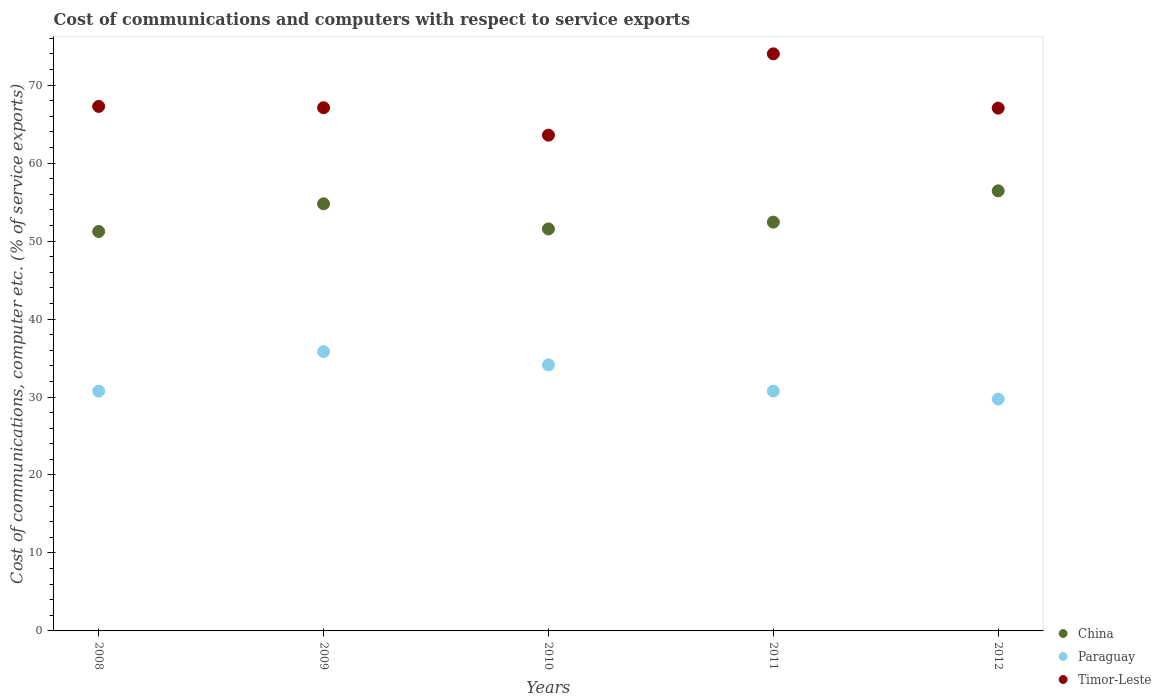How many different coloured dotlines are there?
Give a very brief answer. 3. What is the cost of communications and computers in Timor-Leste in 2011?
Your response must be concise. 74.01. Across all years, what is the maximum cost of communications and computers in Paraguay?
Your answer should be compact. 35.82. Across all years, what is the minimum cost of communications and computers in Timor-Leste?
Give a very brief answer. 63.58. In which year was the cost of communications and computers in China maximum?
Offer a terse response. 2012. What is the total cost of communications and computers in China in the graph?
Ensure brevity in your answer.  266.42. What is the difference between the cost of communications and computers in Timor-Leste in 2008 and that in 2012?
Provide a succinct answer. 0.22. What is the difference between the cost of communications and computers in Paraguay in 2012 and the cost of communications and computers in Timor-Leste in 2008?
Ensure brevity in your answer.  -37.54. What is the average cost of communications and computers in Timor-Leste per year?
Provide a short and direct response. 67.8. In the year 2008, what is the difference between the cost of communications and computers in Timor-Leste and cost of communications and computers in Paraguay?
Offer a terse response. 36.51. What is the ratio of the cost of communications and computers in Timor-Leste in 2009 to that in 2010?
Ensure brevity in your answer.  1.06. Is the cost of communications and computers in Timor-Leste in 2010 less than that in 2012?
Offer a very short reply. Yes. Is the difference between the cost of communications and computers in Timor-Leste in 2010 and 2012 greater than the difference between the cost of communications and computers in Paraguay in 2010 and 2012?
Give a very brief answer. No. What is the difference between the highest and the second highest cost of communications and computers in Paraguay?
Give a very brief answer. 1.7. What is the difference between the highest and the lowest cost of communications and computers in China?
Your response must be concise. 5.21. In how many years, is the cost of communications and computers in Paraguay greater than the average cost of communications and computers in Paraguay taken over all years?
Give a very brief answer. 2. Is the sum of the cost of communications and computers in Paraguay in 2010 and 2011 greater than the maximum cost of communications and computers in China across all years?
Offer a very short reply. Yes. Does the cost of communications and computers in Paraguay monotonically increase over the years?
Your response must be concise. No. How many dotlines are there?
Offer a very short reply. 3. What is the difference between two consecutive major ticks on the Y-axis?
Your response must be concise. 10. Does the graph contain grids?
Make the answer very short. No. Where does the legend appear in the graph?
Make the answer very short. Bottom right. How are the legend labels stacked?
Make the answer very short. Vertical. What is the title of the graph?
Give a very brief answer. Cost of communications and computers with respect to service exports. Does "Qatar" appear as one of the legend labels in the graph?
Ensure brevity in your answer.  No. What is the label or title of the Y-axis?
Offer a very short reply. Cost of communications, computer etc. (% of service exports). What is the Cost of communications, computer etc. (% of service exports) of China in 2008?
Your response must be concise. 51.23. What is the Cost of communications, computer etc. (% of service exports) of Paraguay in 2008?
Your answer should be very brief. 30.76. What is the Cost of communications, computer etc. (% of service exports) in Timor-Leste in 2008?
Make the answer very short. 67.27. What is the Cost of communications, computer etc. (% of service exports) in China in 2009?
Provide a short and direct response. 54.78. What is the Cost of communications, computer etc. (% of service exports) in Paraguay in 2009?
Your answer should be very brief. 35.82. What is the Cost of communications, computer etc. (% of service exports) of Timor-Leste in 2009?
Offer a terse response. 67.1. What is the Cost of communications, computer etc. (% of service exports) of China in 2010?
Offer a terse response. 51.55. What is the Cost of communications, computer etc. (% of service exports) in Paraguay in 2010?
Make the answer very short. 34.12. What is the Cost of communications, computer etc. (% of service exports) in Timor-Leste in 2010?
Your answer should be very brief. 63.58. What is the Cost of communications, computer etc. (% of service exports) in China in 2011?
Your response must be concise. 52.43. What is the Cost of communications, computer etc. (% of service exports) in Paraguay in 2011?
Give a very brief answer. 30.76. What is the Cost of communications, computer etc. (% of service exports) in Timor-Leste in 2011?
Keep it short and to the point. 74.01. What is the Cost of communications, computer etc. (% of service exports) of China in 2012?
Your response must be concise. 56.44. What is the Cost of communications, computer etc. (% of service exports) of Paraguay in 2012?
Keep it short and to the point. 29.73. What is the Cost of communications, computer etc. (% of service exports) in Timor-Leste in 2012?
Make the answer very short. 67.05. Across all years, what is the maximum Cost of communications, computer etc. (% of service exports) in China?
Provide a succinct answer. 56.44. Across all years, what is the maximum Cost of communications, computer etc. (% of service exports) in Paraguay?
Keep it short and to the point. 35.82. Across all years, what is the maximum Cost of communications, computer etc. (% of service exports) of Timor-Leste?
Provide a succinct answer. 74.01. Across all years, what is the minimum Cost of communications, computer etc. (% of service exports) in China?
Your response must be concise. 51.23. Across all years, what is the minimum Cost of communications, computer etc. (% of service exports) of Paraguay?
Your answer should be compact. 29.73. Across all years, what is the minimum Cost of communications, computer etc. (% of service exports) of Timor-Leste?
Give a very brief answer. 63.58. What is the total Cost of communications, computer etc. (% of service exports) in China in the graph?
Offer a very short reply. 266.42. What is the total Cost of communications, computer etc. (% of service exports) in Paraguay in the graph?
Your answer should be compact. 161.18. What is the total Cost of communications, computer etc. (% of service exports) in Timor-Leste in the graph?
Provide a succinct answer. 339.01. What is the difference between the Cost of communications, computer etc. (% of service exports) in China in 2008 and that in 2009?
Your response must be concise. -3.55. What is the difference between the Cost of communications, computer etc. (% of service exports) of Paraguay in 2008 and that in 2009?
Your answer should be compact. -5.06. What is the difference between the Cost of communications, computer etc. (% of service exports) of Timor-Leste in 2008 and that in 2009?
Ensure brevity in your answer.  0.17. What is the difference between the Cost of communications, computer etc. (% of service exports) of China in 2008 and that in 2010?
Provide a succinct answer. -0.33. What is the difference between the Cost of communications, computer etc. (% of service exports) of Paraguay in 2008 and that in 2010?
Offer a terse response. -3.36. What is the difference between the Cost of communications, computer etc. (% of service exports) of Timor-Leste in 2008 and that in 2010?
Make the answer very short. 3.69. What is the difference between the Cost of communications, computer etc. (% of service exports) in China in 2008 and that in 2011?
Your answer should be very brief. -1.2. What is the difference between the Cost of communications, computer etc. (% of service exports) in Paraguay in 2008 and that in 2011?
Make the answer very short. -0. What is the difference between the Cost of communications, computer etc. (% of service exports) of Timor-Leste in 2008 and that in 2011?
Give a very brief answer. -6.74. What is the difference between the Cost of communications, computer etc. (% of service exports) in China in 2008 and that in 2012?
Your response must be concise. -5.21. What is the difference between the Cost of communications, computer etc. (% of service exports) in Timor-Leste in 2008 and that in 2012?
Make the answer very short. 0.22. What is the difference between the Cost of communications, computer etc. (% of service exports) of China in 2009 and that in 2010?
Offer a terse response. 3.23. What is the difference between the Cost of communications, computer etc. (% of service exports) of Paraguay in 2009 and that in 2010?
Give a very brief answer. 1.7. What is the difference between the Cost of communications, computer etc. (% of service exports) in Timor-Leste in 2009 and that in 2010?
Offer a terse response. 3.52. What is the difference between the Cost of communications, computer etc. (% of service exports) in China in 2009 and that in 2011?
Keep it short and to the point. 2.35. What is the difference between the Cost of communications, computer etc. (% of service exports) in Paraguay in 2009 and that in 2011?
Your answer should be very brief. 5.06. What is the difference between the Cost of communications, computer etc. (% of service exports) of Timor-Leste in 2009 and that in 2011?
Your response must be concise. -6.91. What is the difference between the Cost of communications, computer etc. (% of service exports) in China in 2009 and that in 2012?
Make the answer very short. -1.66. What is the difference between the Cost of communications, computer etc. (% of service exports) of Paraguay in 2009 and that in 2012?
Provide a short and direct response. 6.09. What is the difference between the Cost of communications, computer etc. (% of service exports) of Timor-Leste in 2009 and that in 2012?
Give a very brief answer. 0.05. What is the difference between the Cost of communications, computer etc. (% of service exports) of China in 2010 and that in 2011?
Provide a succinct answer. -0.87. What is the difference between the Cost of communications, computer etc. (% of service exports) of Paraguay in 2010 and that in 2011?
Provide a succinct answer. 3.36. What is the difference between the Cost of communications, computer etc. (% of service exports) of Timor-Leste in 2010 and that in 2011?
Your answer should be compact. -10.43. What is the difference between the Cost of communications, computer etc. (% of service exports) of China in 2010 and that in 2012?
Ensure brevity in your answer.  -4.89. What is the difference between the Cost of communications, computer etc. (% of service exports) in Paraguay in 2010 and that in 2012?
Your answer should be compact. 4.39. What is the difference between the Cost of communications, computer etc. (% of service exports) in Timor-Leste in 2010 and that in 2012?
Offer a very short reply. -3.47. What is the difference between the Cost of communications, computer etc. (% of service exports) of China in 2011 and that in 2012?
Your answer should be compact. -4.02. What is the difference between the Cost of communications, computer etc. (% of service exports) in Paraguay in 2011 and that in 2012?
Provide a succinct answer. 1.03. What is the difference between the Cost of communications, computer etc. (% of service exports) of Timor-Leste in 2011 and that in 2012?
Give a very brief answer. 6.96. What is the difference between the Cost of communications, computer etc. (% of service exports) in China in 2008 and the Cost of communications, computer etc. (% of service exports) in Paraguay in 2009?
Your answer should be compact. 15.41. What is the difference between the Cost of communications, computer etc. (% of service exports) of China in 2008 and the Cost of communications, computer etc. (% of service exports) of Timor-Leste in 2009?
Provide a succinct answer. -15.87. What is the difference between the Cost of communications, computer etc. (% of service exports) in Paraguay in 2008 and the Cost of communications, computer etc. (% of service exports) in Timor-Leste in 2009?
Make the answer very short. -36.34. What is the difference between the Cost of communications, computer etc. (% of service exports) of China in 2008 and the Cost of communications, computer etc. (% of service exports) of Paraguay in 2010?
Give a very brief answer. 17.11. What is the difference between the Cost of communications, computer etc. (% of service exports) in China in 2008 and the Cost of communications, computer etc. (% of service exports) in Timor-Leste in 2010?
Give a very brief answer. -12.35. What is the difference between the Cost of communications, computer etc. (% of service exports) of Paraguay in 2008 and the Cost of communications, computer etc. (% of service exports) of Timor-Leste in 2010?
Offer a terse response. -32.82. What is the difference between the Cost of communications, computer etc. (% of service exports) of China in 2008 and the Cost of communications, computer etc. (% of service exports) of Paraguay in 2011?
Your answer should be compact. 20.47. What is the difference between the Cost of communications, computer etc. (% of service exports) in China in 2008 and the Cost of communications, computer etc. (% of service exports) in Timor-Leste in 2011?
Give a very brief answer. -22.78. What is the difference between the Cost of communications, computer etc. (% of service exports) in Paraguay in 2008 and the Cost of communications, computer etc. (% of service exports) in Timor-Leste in 2011?
Offer a terse response. -43.25. What is the difference between the Cost of communications, computer etc. (% of service exports) in China in 2008 and the Cost of communications, computer etc. (% of service exports) in Paraguay in 2012?
Provide a short and direct response. 21.5. What is the difference between the Cost of communications, computer etc. (% of service exports) in China in 2008 and the Cost of communications, computer etc. (% of service exports) in Timor-Leste in 2012?
Ensure brevity in your answer.  -15.82. What is the difference between the Cost of communications, computer etc. (% of service exports) in Paraguay in 2008 and the Cost of communications, computer etc. (% of service exports) in Timor-Leste in 2012?
Your answer should be compact. -36.29. What is the difference between the Cost of communications, computer etc. (% of service exports) in China in 2009 and the Cost of communications, computer etc. (% of service exports) in Paraguay in 2010?
Keep it short and to the point. 20.66. What is the difference between the Cost of communications, computer etc. (% of service exports) in China in 2009 and the Cost of communications, computer etc. (% of service exports) in Timor-Leste in 2010?
Offer a very short reply. -8.8. What is the difference between the Cost of communications, computer etc. (% of service exports) of Paraguay in 2009 and the Cost of communications, computer etc. (% of service exports) of Timor-Leste in 2010?
Provide a succinct answer. -27.76. What is the difference between the Cost of communications, computer etc. (% of service exports) in China in 2009 and the Cost of communications, computer etc. (% of service exports) in Paraguay in 2011?
Your response must be concise. 24.02. What is the difference between the Cost of communications, computer etc. (% of service exports) of China in 2009 and the Cost of communications, computer etc. (% of service exports) of Timor-Leste in 2011?
Offer a terse response. -19.23. What is the difference between the Cost of communications, computer etc. (% of service exports) in Paraguay in 2009 and the Cost of communications, computer etc. (% of service exports) in Timor-Leste in 2011?
Your answer should be compact. -38.19. What is the difference between the Cost of communications, computer etc. (% of service exports) in China in 2009 and the Cost of communications, computer etc. (% of service exports) in Paraguay in 2012?
Keep it short and to the point. 25.05. What is the difference between the Cost of communications, computer etc. (% of service exports) of China in 2009 and the Cost of communications, computer etc. (% of service exports) of Timor-Leste in 2012?
Offer a terse response. -12.27. What is the difference between the Cost of communications, computer etc. (% of service exports) in Paraguay in 2009 and the Cost of communications, computer etc. (% of service exports) in Timor-Leste in 2012?
Make the answer very short. -31.23. What is the difference between the Cost of communications, computer etc. (% of service exports) of China in 2010 and the Cost of communications, computer etc. (% of service exports) of Paraguay in 2011?
Your answer should be compact. 20.79. What is the difference between the Cost of communications, computer etc. (% of service exports) of China in 2010 and the Cost of communications, computer etc. (% of service exports) of Timor-Leste in 2011?
Give a very brief answer. -22.46. What is the difference between the Cost of communications, computer etc. (% of service exports) in Paraguay in 2010 and the Cost of communications, computer etc. (% of service exports) in Timor-Leste in 2011?
Provide a succinct answer. -39.89. What is the difference between the Cost of communications, computer etc. (% of service exports) of China in 2010 and the Cost of communications, computer etc. (% of service exports) of Paraguay in 2012?
Offer a terse response. 21.82. What is the difference between the Cost of communications, computer etc. (% of service exports) of China in 2010 and the Cost of communications, computer etc. (% of service exports) of Timor-Leste in 2012?
Provide a succinct answer. -15.49. What is the difference between the Cost of communications, computer etc. (% of service exports) in Paraguay in 2010 and the Cost of communications, computer etc. (% of service exports) in Timor-Leste in 2012?
Make the answer very short. -32.93. What is the difference between the Cost of communications, computer etc. (% of service exports) in China in 2011 and the Cost of communications, computer etc. (% of service exports) in Paraguay in 2012?
Make the answer very short. 22.7. What is the difference between the Cost of communications, computer etc. (% of service exports) in China in 2011 and the Cost of communications, computer etc. (% of service exports) in Timor-Leste in 2012?
Your response must be concise. -14.62. What is the difference between the Cost of communications, computer etc. (% of service exports) in Paraguay in 2011 and the Cost of communications, computer etc. (% of service exports) in Timor-Leste in 2012?
Keep it short and to the point. -36.29. What is the average Cost of communications, computer etc. (% of service exports) of China per year?
Your answer should be compact. 53.28. What is the average Cost of communications, computer etc. (% of service exports) in Paraguay per year?
Offer a very short reply. 32.24. What is the average Cost of communications, computer etc. (% of service exports) in Timor-Leste per year?
Your answer should be compact. 67.8. In the year 2008, what is the difference between the Cost of communications, computer etc. (% of service exports) in China and Cost of communications, computer etc. (% of service exports) in Paraguay?
Offer a very short reply. 20.47. In the year 2008, what is the difference between the Cost of communications, computer etc. (% of service exports) of China and Cost of communications, computer etc. (% of service exports) of Timor-Leste?
Give a very brief answer. -16.04. In the year 2008, what is the difference between the Cost of communications, computer etc. (% of service exports) of Paraguay and Cost of communications, computer etc. (% of service exports) of Timor-Leste?
Offer a terse response. -36.51. In the year 2009, what is the difference between the Cost of communications, computer etc. (% of service exports) of China and Cost of communications, computer etc. (% of service exports) of Paraguay?
Provide a succinct answer. 18.96. In the year 2009, what is the difference between the Cost of communications, computer etc. (% of service exports) in China and Cost of communications, computer etc. (% of service exports) in Timor-Leste?
Your answer should be compact. -12.32. In the year 2009, what is the difference between the Cost of communications, computer etc. (% of service exports) of Paraguay and Cost of communications, computer etc. (% of service exports) of Timor-Leste?
Your answer should be very brief. -31.28. In the year 2010, what is the difference between the Cost of communications, computer etc. (% of service exports) of China and Cost of communications, computer etc. (% of service exports) of Paraguay?
Make the answer very short. 17.44. In the year 2010, what is the difference between the Cost of communications, computer etc. (% of service exports) of China and Cost of communications, computer etc. (% of service exports) of Timor-Leste?
Ensure brevity in your answer.  -12.03. In the year 2010, what is the difference between the Cost of communications, computer etc. (% of service exports) of Paraguay and Cost of communications, computer etc. (% of service exports) of Timor-Leste?
Ensure brevity in your answer.  -29.46. In the year 2011, what is the difference between the Cost of communications, computer etc. (% of service exports) of China and Cost of communications, computer etc. (% of service exports) of Paraguay?
Give a very brief answer. 21.67. In the year 2011, what is the difference between the Cost of communications, computer etc. (% of service exports) in China and Cost of communications, computer etc. (% of service exports) in Timor-Leste?
Your answer should be compact. -21.59. In the year 2011, what is the difference between the Cost of communications, computer etc. (% of service exports) in Paraguay and Cost of communications, computer etc. (% of service exports) in Timor-Leste?
Provide a short and direct response. -43.25. In the year 2012, what is the difference between the Cost of communications, computer etc. (% of service exports) of China and Cost of communications, computer etc. (% of service exports) of Paraguay?
Keep it short and to the point. 26.71. In the year 2012, what is the difference between the Cost of communications, computer etc. (% of service exports) in China and Cost of communications, computer etc. (% of service exports) in Timor-Leste?
Give a very brief answer. -10.61. In the year 2012, what is the difference between the Cost of communications, computer etc. (% of service exports) of Paraguay and Cost of communications, computer etc. (% of service exports) of Timor-Leste?
Your answer should be very brief. -37.32. What is the ratio of the Cost of communications, computer etc. (% of service exports) of China in 2008 to that in 2009?
Make the answer very short. 0.94. What is the ratio of the Cost of communications, computer etc. (% of service exports) of Paraguay in 2008 to that in 2009?
Your response must be concise. 0.86. What is the ratio of the Cost of communications, computer etc. (% of service exports) in Timor-Leste in 2008 to that in 2009?
Keep it short and to the point. 1. What is the ratio of the Cost of communications, computer etc. (% of service exports) in Paraguay in 2008 to that in 2010?
Give a very brief answer. 0.9. What is the ratio of the Cost of communications, computer etc. (% of service exports) of Timor-Leste in 2008 to that in 2010?
Make the answer very short. 1.06. What is the ratio of the Cost of communications, computer etc. (% of service exports) of China in 2008 to that in 2011?
Your answer should be compact. 0.98. What is the ratio of the Cost of communications, computer etc. (% of service exports) of Paraguay in 2008 to that in 2011?
Provide a succinct answer. 1. What is the ratio of the Cost of communications, computer etc. (% of service exports) of Timor-Leste in 2008 to that in 2011?
Provide a short and direct response. 0.91. What is the ratio of the Cost of communications, computer etc. (% of service exports) of China in 2008 to that in 2012?
Provide a short and direct response. 0.91. What is the ratio of the Cost of communications, computer etc. (% of service exports) in Paraguay in 2008 to that in 2012?
Make the answer very short. 1.03. What is the ratio of the Cost of communications, computer etc. (% of service exports) of China in 2009 to that in 2010?
Ensure brevity in your answer.  1.06. What is the ratio of the Cost of communications, computer etc. (% of service exports) of Paraguay in 2009 to that in 2010?
Keep it short and to the point. 1.05. What is the ratio of the Cost of communications, computer etc. (% of service exports) in Timor-Leste in 2009 to that in 2010?
Keep it short and to the point. 1.06. What is the ratio of the Cost of communications, computer etc. (% of service exports) of China in 2009 to that in 2011?
Offer a very short reply. 1.04. What is the ratio of the Cost of communications, computer etc. (% of service exports) in Paraguay in 2009 to that in 2011?
Provide a succinct answer. 1.16. What is the ratio of the Cost of communications, computer etc. (% of service exports) of Timor-Leste in 2009 to that in 2011?
Your response must be concise. 0.91. What is the ratio of the Cost of communications, computer etc. (% of service exports) of China in 2009 to that in 2012?
Your answer should be very brief. 0.97. What is the ratio of the Cost of communications, computer etc. (% of service exports) of Paraguay in 2009 to that in 2012?
Offer a very short reply. 1.2. What is the ratio of the Cost of communications, computer etc. (% of service exports) in China in 2010 to that in 2011?
Your answer should be compact. 0.98. What is the ratio of the Cost of communications, computer etc. (% of service exports) of Paraguay in 2010 to that in 2011?
Make the answer very short. 1.11. What is the ratio of the Cost of communications, computer etc. (% of service exports) of Timor-Leste in 2010 to that in 2011?
Keep it short and to the point. 0.86. What is the ratio of the Cost of communications, computer etc. (% of service exports) of China in 2010 to that in 2012?
Your answer should be very brief. 0.91. What is the ratio of the Cost of communications, computer etc. (% of service exports) in Paraguay in 2010 to that in 2012?
Offer a terse response. 1.15. What is the ratio of the Cost of communications, computer etc. (% of service exports) in Timor-Leste in 2010 to that in 2012?
Your answer should be compact. 0.95. What is the ratio of the Cost of communications, computer etc. (% of service exports) in China in 2011 to that in 2012?
Your answer should be compact. 0.93. What is the ratio of the Cost of communications, computer etc. (% of service exports) in Paraguay in 2011 to that in 2012?
Ensure brevity in your answer.  1.03. What is the ratio of the Cost of communications, computer etc. (% of service exports) of Timor-Leste in 2011 to that in 2012?
Give a very brief answer. 1.1. What is the difference between the highest and the second highest Cost of communications, computer etc. (% of service exports) in China?
Provide a short and direct response. 1.66. What is the difference between the highest and the second highest Cost of communications, computer etc. (% of service exports) of Paraguay?
Offer a terse response. 1.7. What is the difference between the highest and the second highest Cost of communications, computer etc. (% of service exports) of Timor-Leste?
Keep it short and to the point. 6.74. What is the difference between the highest and the lowest Cost of communications, computer etc. (% of service exports) of China?
Make the answer very short. 5.21. What is the difference between the highest and the lowest Cost of communications, computer etc. (% of service exports) in Paraguay?
Offer a terse response. 6.09. What is the difference between the highest and the lowest Cost of communications, computer etc. (% of service exports) of Timor-Leste?
Your answer should be compact. 10.43. 